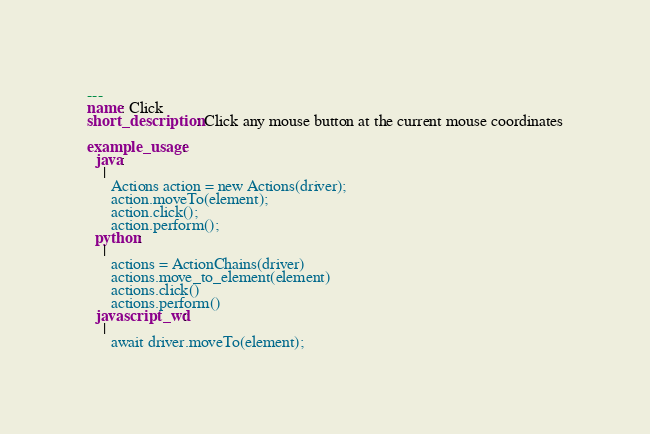<code> <loc_0><loc_0><loc_500><loc_500><_YAML_>---
name: Click
short_description: Click any mouse button at the current mouse coordinates

example_usage:
  java:
    |
      Actions action = new Actions(driver);
      action.moveTo(element);
      action.click();
      action.perform();
  python:
    |
      actions = ActionChains(driver)
      actions.move_to_element(element)
      actions.click()
      actions.perform()
  javascript_wd:
    |
      await driver.moveTo(element);</code> 